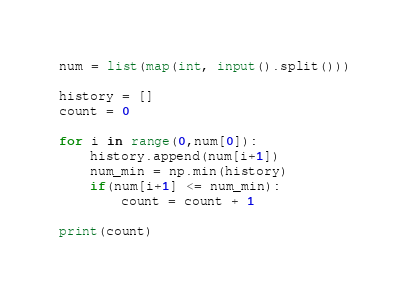<code> <loc_0><loc_0><loc_500><loc_500><_Python_>num = list(map(int, input().split()))

history = []
count = 0

for i in range(0,num[0]):
    history.append(num[i+1])
    num_min = np.min(history)
    if(num[i+1] <= num_min):
        count = count + 1

print(count)</code> 